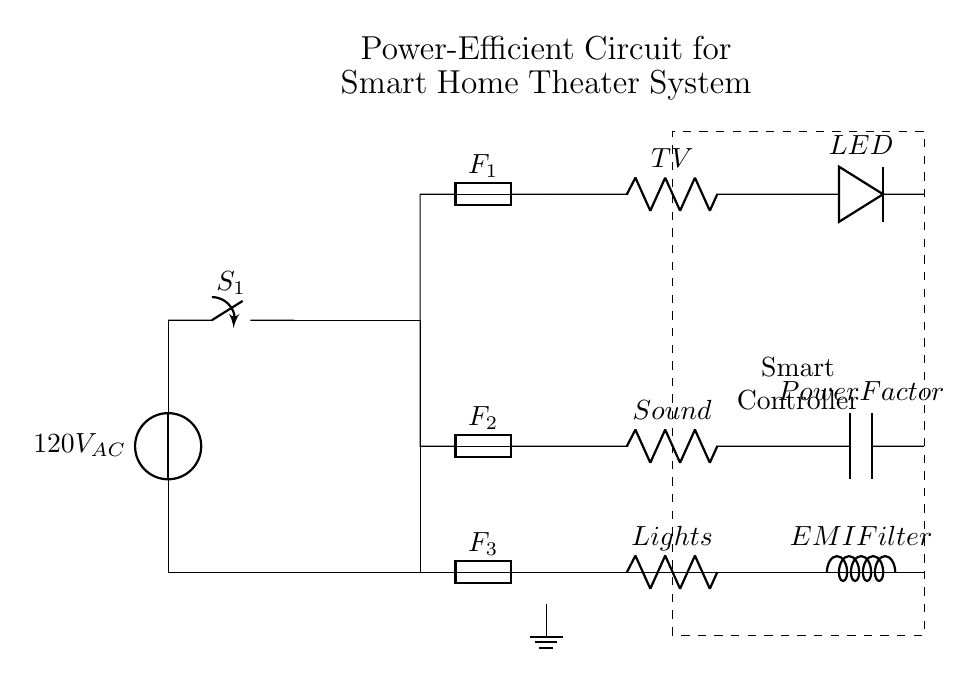What is the voltage supply for this circuit? The circuit is powered by a source labeled as 120V AC, indicating the voltage supply provided to the system.
Answer: 120V AC What components are in the power distribution section? In the power distribution section, there are fuses labeled F1, F2, and F3, which distribute power to the Smart TV, Sound System, and Lights respectively.
Answer: F1, F2, F3 What is the role of the smart controller? The smart controller is represented by a dashed rectangle and is mentioned as managing the overall operation of the circuit, indicating its function is to intelligently control the connected devices.
Answer: Managing operation Which component serves as an EMI filter in this circuit? The component labeled as L, positioned in the Lights branch, indicates it functions as an EMI filter, which helps reduce electromagnetic interference in the circuit.
Answer: EMI Filter What is connected to the Smart TV in terms of energy efficiency? The LED, shown in series with the Smart TV, denotes that it is an energy-efficient lighting component that complements the TV's operation.
Answer: LED How do the fuses contribute to circuit safety? The fuses (F1, F2, F3) provide overcurrent protection for each branch in the circuit by interrupting the flow of electricity if a fault occurs, thus protecting connected devices from damage.
Answer: Overcurrent protection 